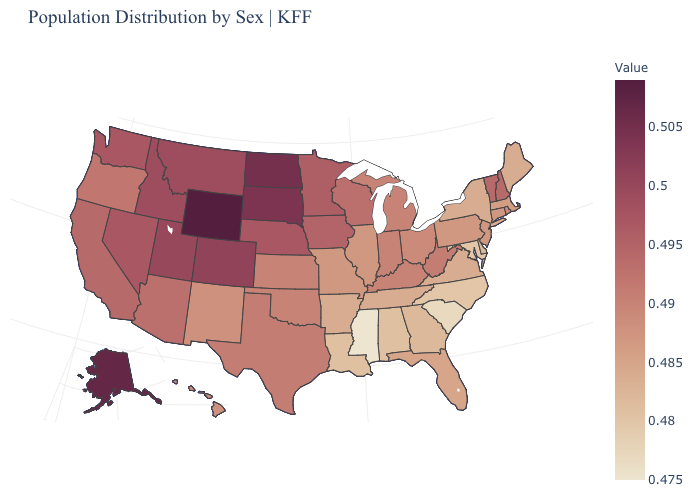Does Wyoming have the highest value in the West?
Give a very brief answer. Yes. Among the states that border Florida , does Georgia have the lowest value?
Write a very short answer. No. Does Mississippi have the lowest value in the USA?
Give a very brief answer. Yes. Which states have the lowest value in the USA?
Concise answer only. Mississippi. 